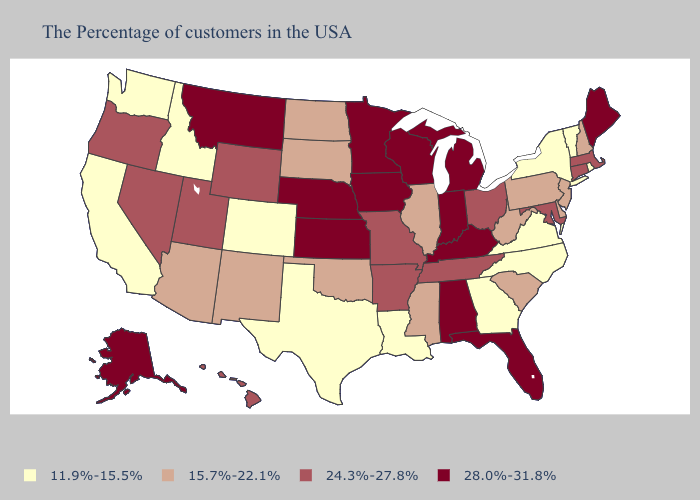Name the states that have a value in the range 28.0%-31.8%?
Give a very brief answer. Maine, Florida, Michigan, Kentucky, Indiana, Alabama, Wisconsin, Minnesota, Iowa, Kansas, Nebraska, Montana, Alaska. Among the states that border Wisconsin , does Illinois have the highest value?
Concise answer only. No. Which states have the lowest value in the MidWest?
Keep it brief. Illinois, South Dakota, North Dakota. Does Colorado have the lowest value in the USA?
Keep it brief. Yes. What is the value of Florida?
Keep it brief. 28.0%-31.8%. Does the first symbol in the legend represent the smallest category?
Short answer required. Yes. What is the value of Arizona?
Answer briefly. 15.7%-22.1%. What is the value of Louisiana?
Concise answer only. 11.9%-15.5%. What is the value of Alabama?
Be succinct. 28.0%-31.8%. Name the states that have a value in the range 24.3%-27.8%?
Be succinct. Massachusetts, Connecticut, Maryland, Ohio, Tennessee, Missouri, Arkansas, Wyoming, Utah, Nevada, Oregon, Hawaii. What is the value of Maine?
Short answer required. 28.0%-31.8%. Name the states that have a value in the range 11.9%-15.5%?
Give a very brief answer. Rhode Island, Vermont, New York, Virginia, North Carolina, Georgia, Louisiana, Texas, Colorado, Idaho, California, Washington. Does Ohio have the lowest value in the USA?
Keep it brief. No. How many symbols are there in the legend?
Answer briefly. 4. 